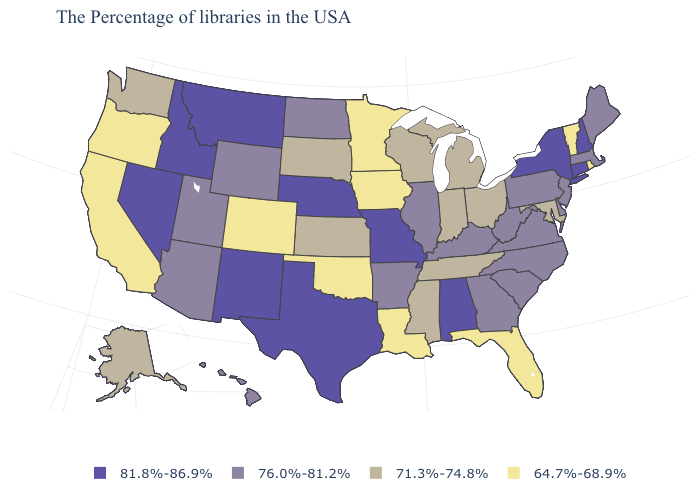Does the first symbol in the legend represent the smallest category?
Quick response, please. No. Among the states that border Tennessee , does Mississippi have the lowest value?
Give a very brief answer. Yes. Name the states that have a value in the range 71.3%-74.8%?
Quick response, please. Maryland, Ohio, Michigan, Indiana, Tennessee, Wisconsin, Mississippi, Kansas, South Dakota, Washington, Alaska. What is the highest value in the USA?
Answer briefly. 81.8%-86.9%. Among the states that border Idaho , does Nevada have the highest value?
Be succinct. Yes. What is the value of Nebraska?
Keep it brief. 81.8%-86.9%. Among the states that border Minnesota , which have the highest value?
Give a very brief answer. North Dakota. Which states have the highest value in the USA?
Short answer required. New Hampshire, Connecticut, New York, Alabama, Missouri, Nebraska, Texas, New Mexico, Montana, Idaho, Nevada. Name the states that have a value in the range 71.3%-74.8%?
Concise answer only. Maryland, Ohio, Michigan, Indiana, Tennessee, Wisconsin, Mississippi, Kansas, South Dakota, Washington, Alaska. Does Alabama have the lowest value in the USA?
Write a very short answer. No. Is the legend a continuous bar?
Write a very short answer. No. Does the map have missing data?
Answer briefly. No. Name the states that have a value in the range 71.3%-74.8%?
Concise answer only. Maryland, Ohio, Michigan, Indiana, Tennessee, Wisconsin, Mississippi, Kansas, South Dakota, Washington, Alaska. What is the lowest value in states that border North Carolina?
Write a very short answer. 71.3%-74.8%. 